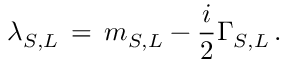Convert formula to latex. <formula><loc_0><loc_0><loc_500><loc_500>\lambda _ { S , L } \, = \, m _ { S , L } - \frac { i } { 2 } \Gamma _ { S , L } \, .</formula> 